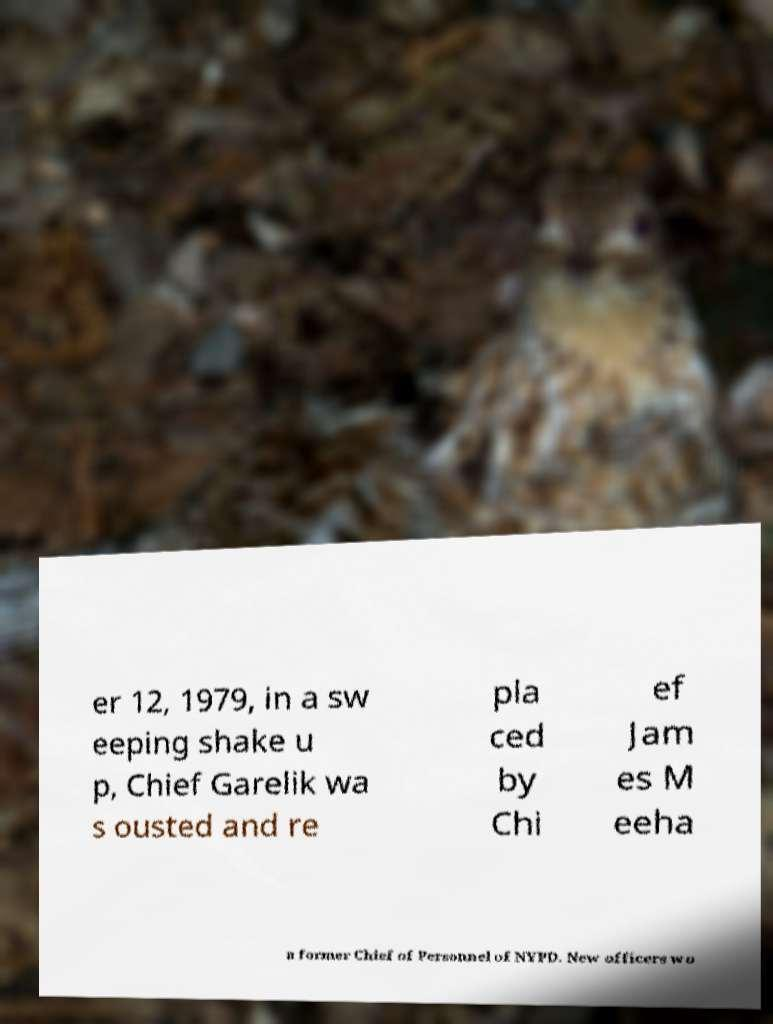What messages or text are displayed in this image? I need them in a readable, typed format. er 12, 1979, in a sw eeping shake u p, Chief Garelik wa s ousted and re pla ced by Chi ef Jam es M eeha n former Chief of Personnel of NYPD. New officers wo 